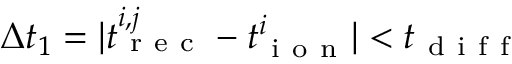<formula> <loc_0><loc_0><loc_500><loc_500>\Delta t _ { 1 } = | t _ { r e c } ^ { i , j } - t _ { i o n } ^ { i } | < t _ { d i f f }</formula> 